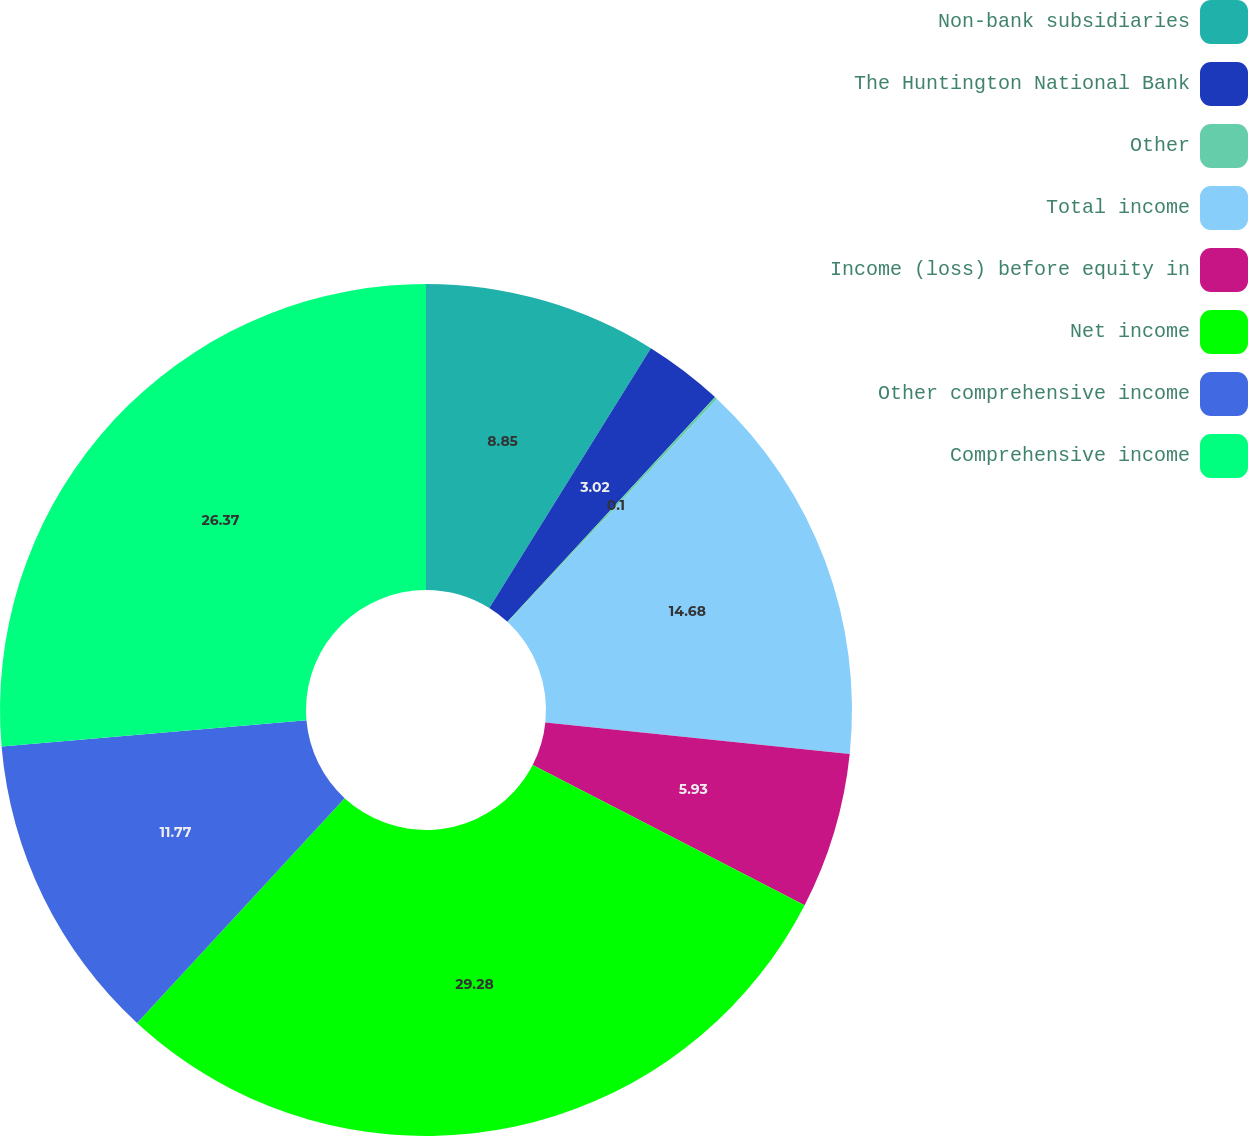Convert chart. <chart><loc_0><loc_0><loc_500><loc_500><pie_chart><fcel>Non-bank subsidiaries<fcel>The Huntington National Bank<fcel>Other<fcel>Total income<fcel>Income (loss) before equity in<fcel>Net income<fcel>Other comprehensive income<fcel>Comprehensive income<nl><fcel>8.85%<fcel>3.02%<fcel>0.1%<fcel>14.68%<fcel>5.93%<fcel>29.29%<fcel>11.77%<fcel>26.37%<nl></chart> 